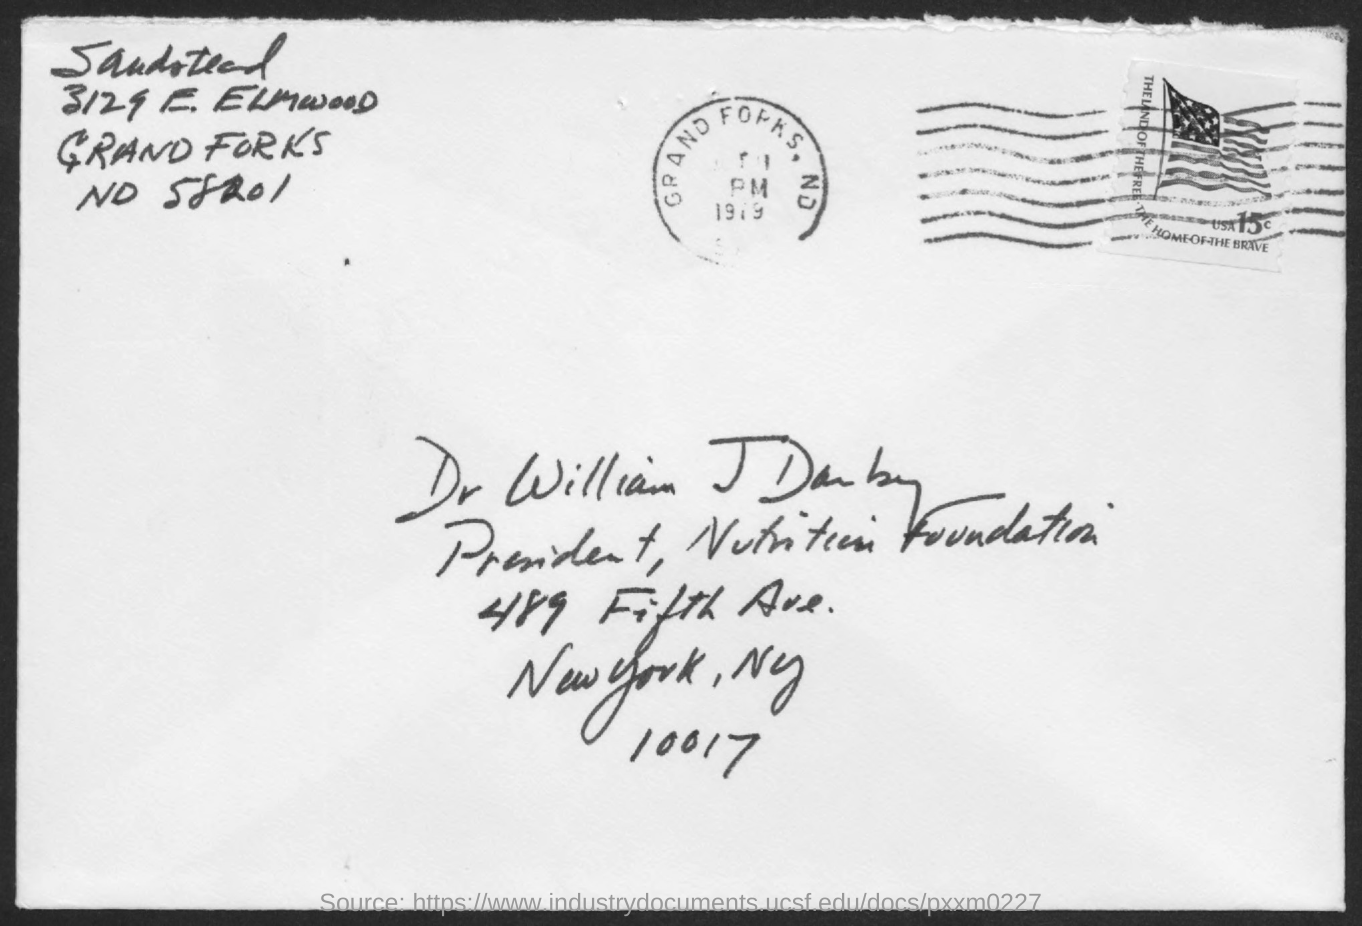What is the name of the person given in the address?
Your response must be concise. Dr. William J. Darby. What is the designation of William J Darby?
Your answer should be compact. President, Nutrition Foundation. 